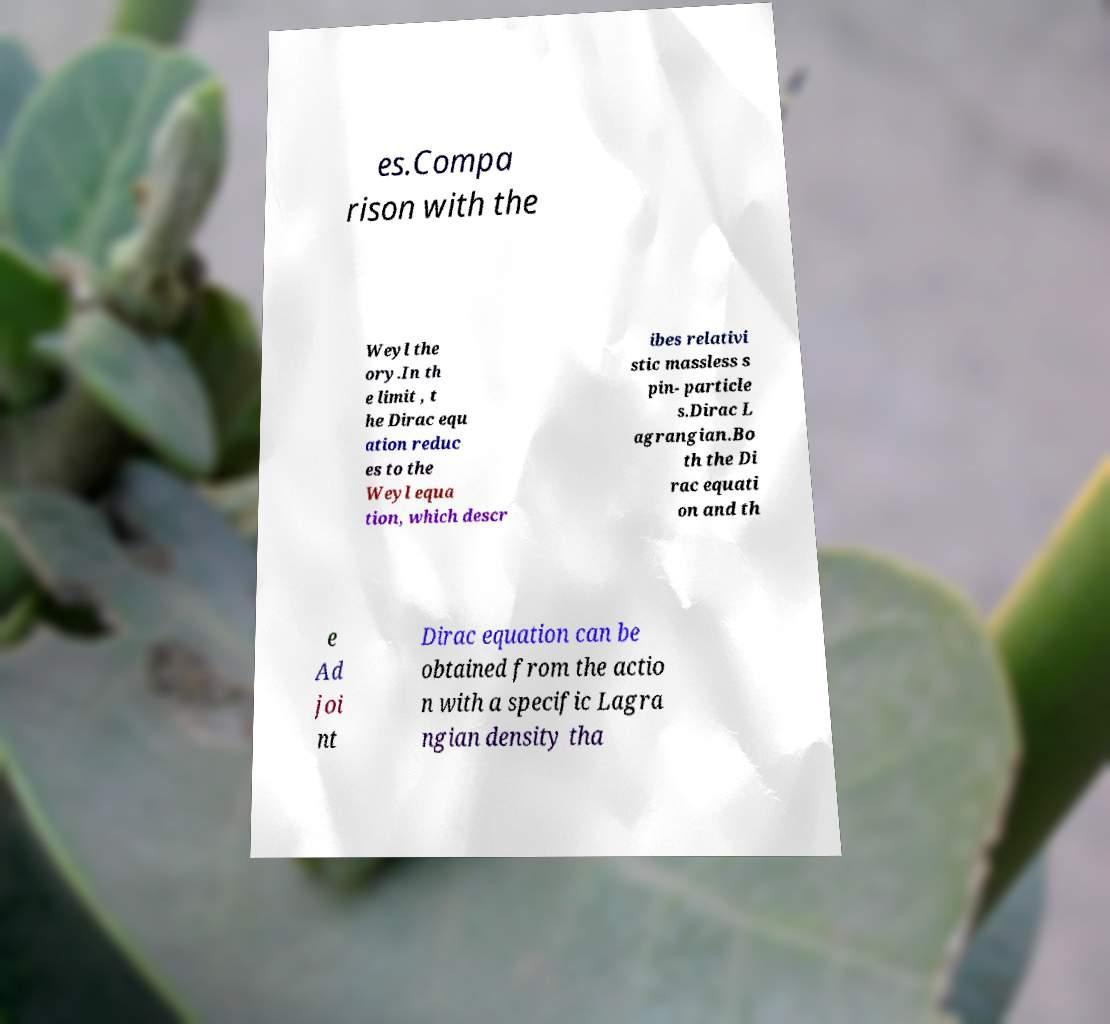Can you accurately transcribe the text from the provided image for me? es.Compa rison with the Weyl the ory.In th e limit , t he Dirac equ ation reduc es to the Weyl equa tion, which descr ibes relativi stic massless s pin- particle s.Dirac L agrangian.Bo th the Di rac equati on and th e Ad joi nt Dirac equation can be obtained from the actio n with a specific Lagra ngian density tha 